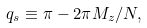<formula> <loc_0><loc_0><loc_500><loc_500>q _ { s } \equiv \pi - 2 \pi M _ { z } / N ,</formula> 